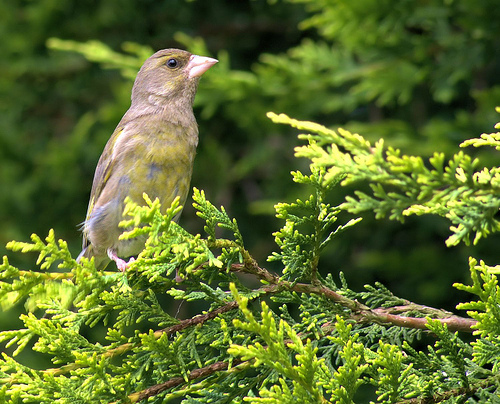How many birds are in the picture? 1 